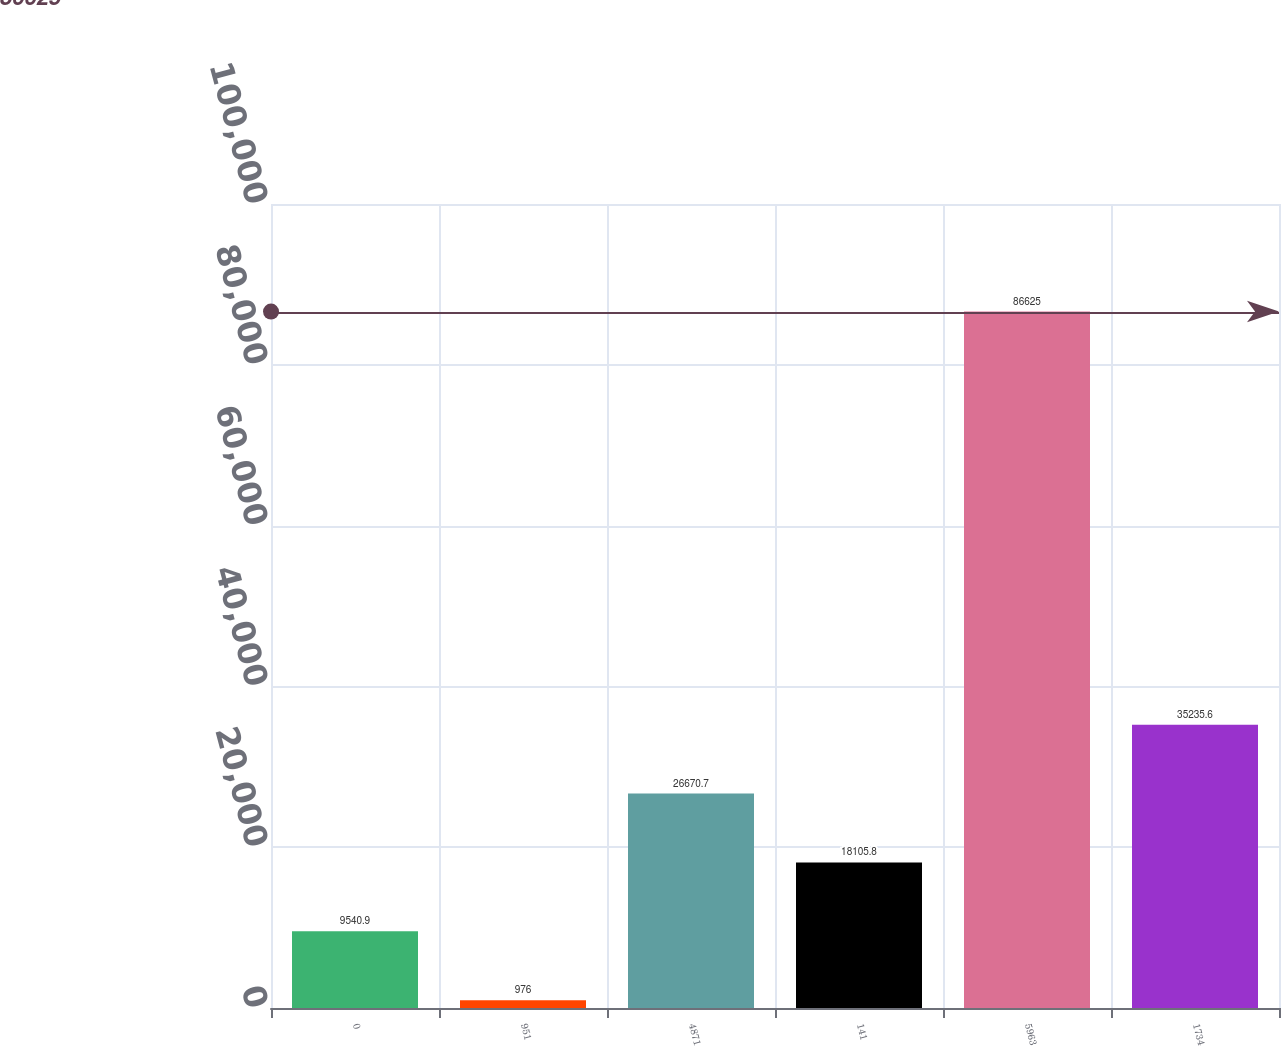Convert chart. <chart><loc_0><loc_0><loc_500><loc_500><bar_chart><fcel>0<fcel>951<fcel>4871<fcel>141<fcel>5963<fcel>1734<nl><fcel>9540.9<fcel>976<fcel>26670.7<fcel>18105.8<fcel>86625<fcel>35235.6<nl></chart> 